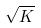Convert formula to latex. <formula><loc_0><loc_0><loc_500><loc_500>\sqrt { K }</formula> 